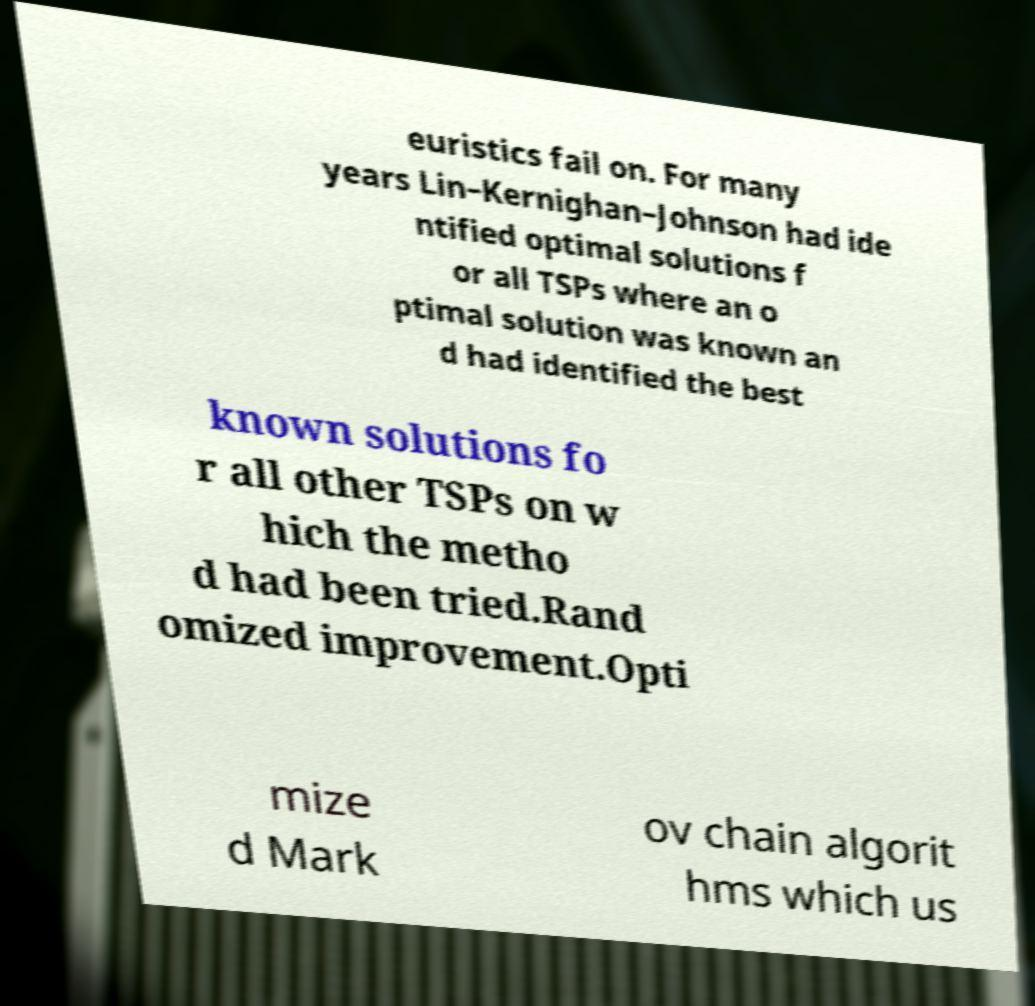Please read and relay the text visible in this image. What does it say? euristics fail on. For many years Lin–Kernighan–Johnson had ide ntified optimal solutions f or all TSPs where an o ptimal solution was known an d had identified the best known solutions fo r all other TSPs on w hich the metho d had been tried.Rand omized improvement.Opti mize d Mark ov chain algorit hms which us 